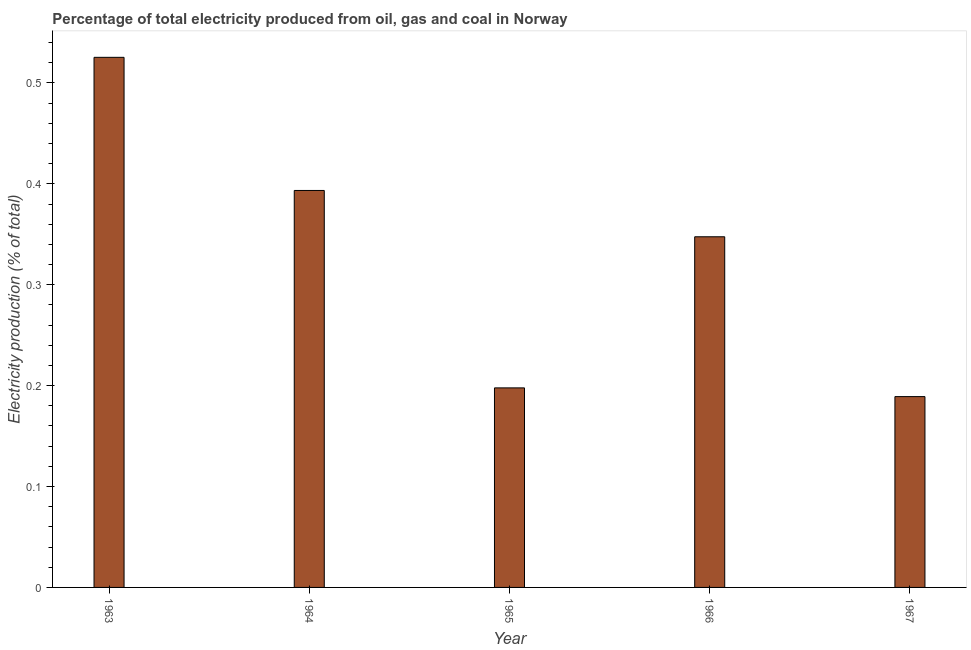Does the graph contain any zero values?
Offer a terse response. No. What is the title of the graph?
Your answer should be very brief. Percentage of total electricity produced from oil, gas and coal in Norway. What is the label or title of the Y-axis?
Offer a terse response. Electricity production (% of total). What is the electricity production in 1965?
Ensure brevity in your answer.  0.2. Across all years, what is the maximum electricity production?
Give a very brief answer. 0.53. Across all years, what is the minimum electricity production?
Keep it short and to the point. 0.19. In which year was the electricity production minimum?
Give a very brief answer. 1967. What is the sum of the electricity production?
Your answer should be compact. 1.65. What is the difference between the electricity production in 1964 and 1965?
Provide a short and direct response. 0.2. What is the average electricity production per year?
Provide a short and direct response. 0.33. What is the median electricity production?
Offer a very short reply. 0.35. Do a majority of the years between 1964 and 1963 (inclusive) have electricity production greater than 0.34 %?
Offer a terse response. No. What is the ratio of the electricity production in 1963 to that in 1966?
Your answer should be compact. 1.51. Is the electricity production in 1964 less than that in 1965?
Provide a succinct answer. No. Is the difference between the electricity production in 1963 and 1965 greater than the difference between any two years?
Provide a short and direct response. No. What is the difference between the highest and the second highest electricity production?
Make the answer very short. 0.13. What is the difference between the highest and the lowest electricity production?
Your answer should be compact. 0.34. What is the difference between two consecutive major ticks on the Y-axis?
Make the answer very short. 0.1. What is the Electricity production (% of total) in 1963?
Offer a very short reply. 0.53. What is the Electricity production (% of total) of 1964?
Offer a very short reply. 0.39. What is the Electricity production (% of total) of 1965?
Provide a succinct answer. 0.2. What is the Electricity production (% of total) in 1966?
Ensure brevity in your answer.  0.35. What is the Electricity production (% of total) of 1967?
Keep it short and to the point. 0.19. What is the difference between the Electricity production (% of total) in 1963 and 1964?
Your answer should be very brief. 0.13. What is the difference between the Electricity production (% of total) in 1963 and 1965?
Provide a succinct answer. 0.33. What is the difference between the Electricity production (% of total) in 1963 and 1966?
Your answer should be compact. 0.18. What is the difference between the Electricity production (% of total) in 1963 and 1967?
Your answer should be very brief. 0.34. What is the difference between the Electricity production (% of total) in 1964 and 1965?
Give a very brief answer. 0.2. What is the difference between the Electricity production (% of total) in 1964 and 1966?
Keep it short and to the point. 0.05. What is the difference between the Electricity production (% of total) in 1964 and 1967?
Your answer should be very brief. 0.2. What is the difference between the Electricity production (% of total) in 1965 and 1966?
Your response must be concise. -0.15. What is the difference between the Electricity production (% of total) in 1965 and 1967?
Offer a terse response. 0.01. What is the difference between the Electricity production (% of total) in 1966 and 1967?
Give a very brief answer. 0.16. What is the ratio of the Electricity production (% of total) in 1963 to that in 1964?
Make the answer very short. 1.33. What is the ratio of the Electricity production (% of total) in 1963 to that in 1965?
Make the answer very short. 2.66. What is the ratio of the Electricity production (% of total) in 1963 to that in 1966?
Your answer should be compact. 1.51. What is the ratio of the Electricity production (% of total) in 1963 to that in 1967?
Your answer should be very brief. 2.78. What is the ratio of the Electricity production (% of total) in 1964 to that in 1965?
Provide a short and direct response. 1.99. What is the ratio of the Electricity production (% of total) in 1964 to that in 1966?
Make the answer very short. 1.13. What is the ratio of the Electricity production (% of total) in 1964 to that in 1967?
Make the answer very short. 2.08. What is the ratio of the Electricity production (% of total) in 1965 to that in 1966?
Your response must be concise. 0.57. What is the ratio of the Electricity production (% of total) in 1965 to that in 1967?
Offer a very short reply. 1.05. What is the ratio of the Electricity production (% of total) in 1966 to that in 1967?
Give a very brief answer. 1.84. 